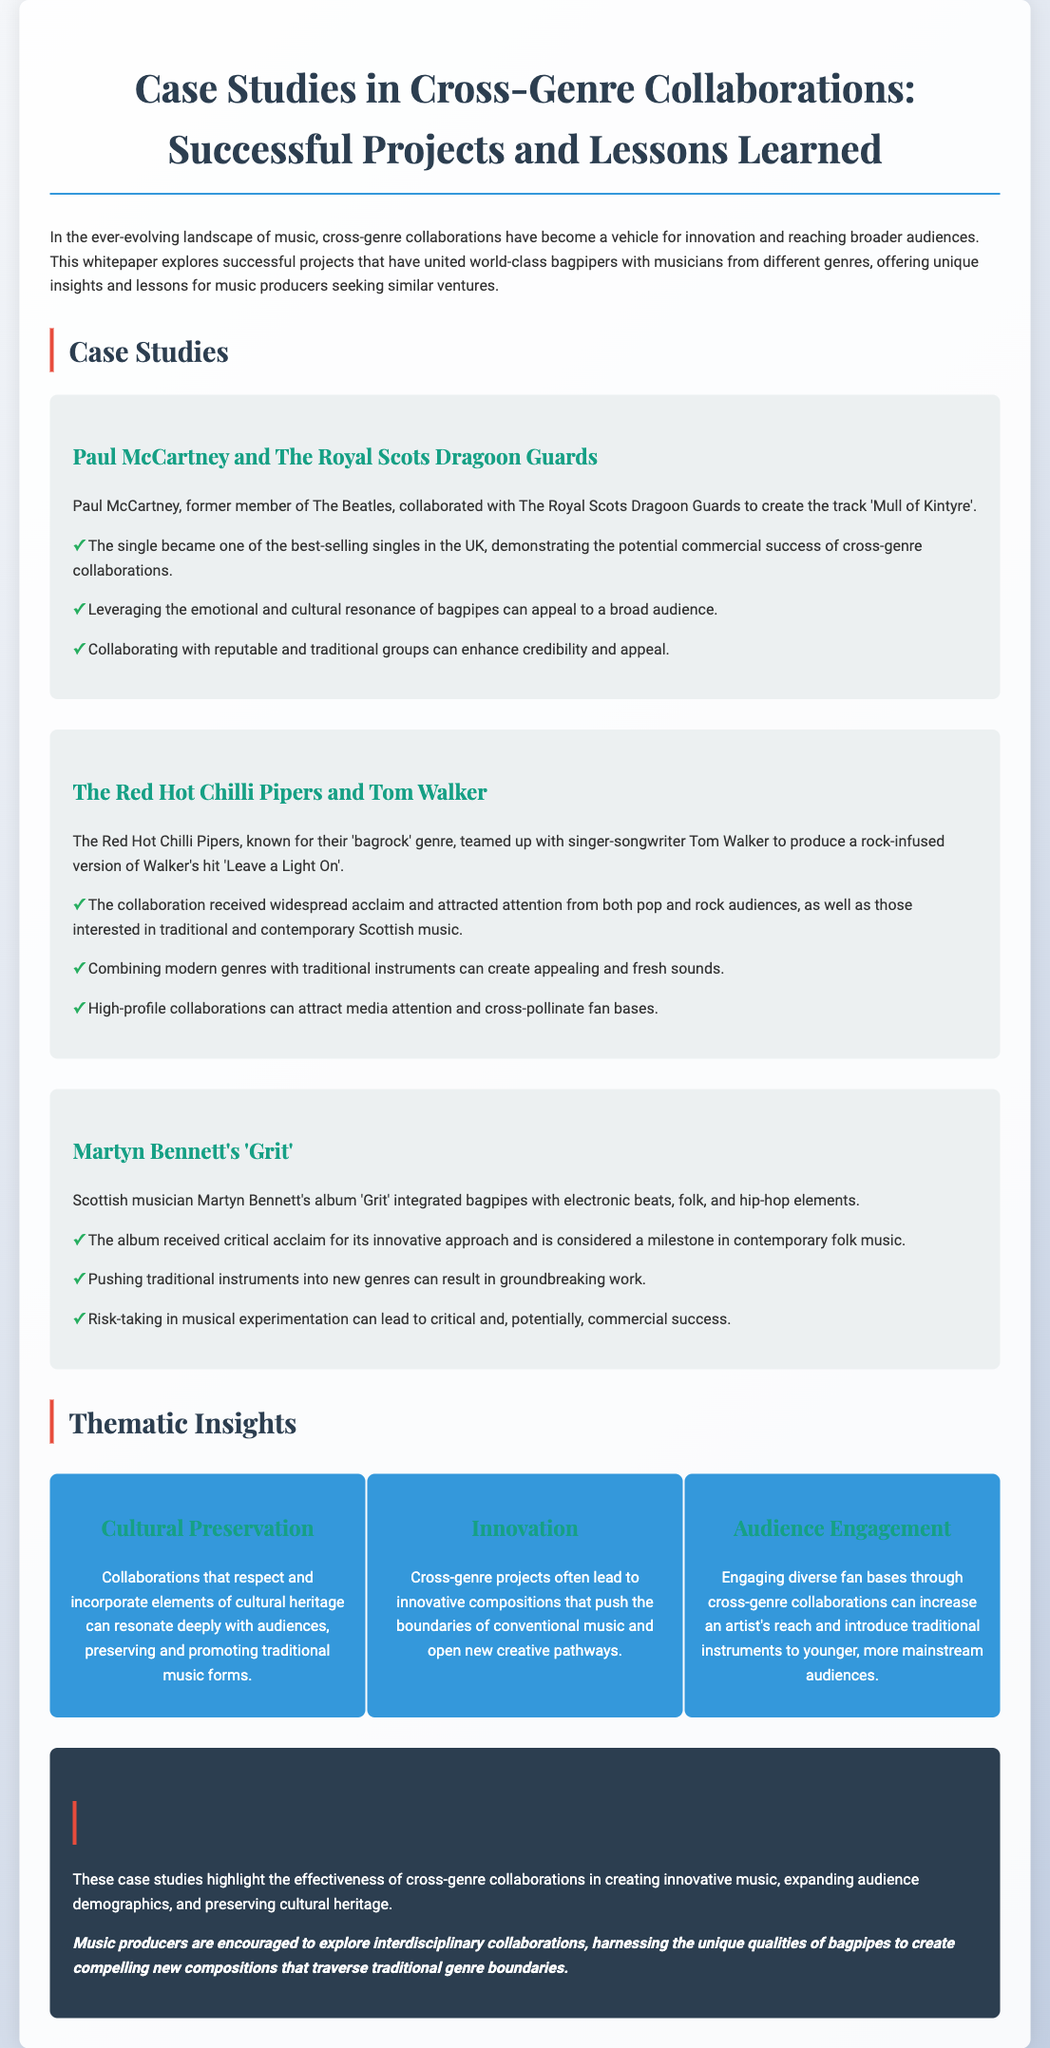what is the title of the document? The title is mentioned prominently at the top of the document, indicating the focus on case studies in cross-genre collaborations.
Answer: Case Studies in Cross-Genre Collaborations: Successful Projects and Lessons Learned who collaborated with The Royal Scots Dragoon Guards? The document specifies Paul McCartney as the artist who collaborated with The Royal Scots Dragoon Guards.
Answer: Paul McCartney what genre did The Red Hot Chilli Pipers bring to Tom Walker's song? The document mentions that The Red Hot Chilli Pipers created a rock-infused version of the song.
Answer: Rock-infused how many case studies are presented in the document? The document outlines three case studies that showcase different collaborations involving bagpipes.
Answer: Three what outcome was noted for Martyn Bennett's album 'Grit'? The document highlights that the album received critical acclaim for its innovative approach.
Answer: Critical acclaim which collaboration is cited for demonstrating the potential commercial success? The collaboration mentioned in the document for its commercial success is between Paul McCartney and The Royal Scots Dragoon Guards.
Answer: Paul McCartney and The Royal Scots Dragoon Guards what is one thematic insight regarding audience engagement? The document notes that engaging diverse fan bases through collaborations can increase an artist's reach.
Answer: Increase an artist's reach what lesson is emphasized regarding traditional instruments? The document suggests that pushing traditional instruments into new genres can lead to groundbreaking work.
Answer: Groundbreaking work 